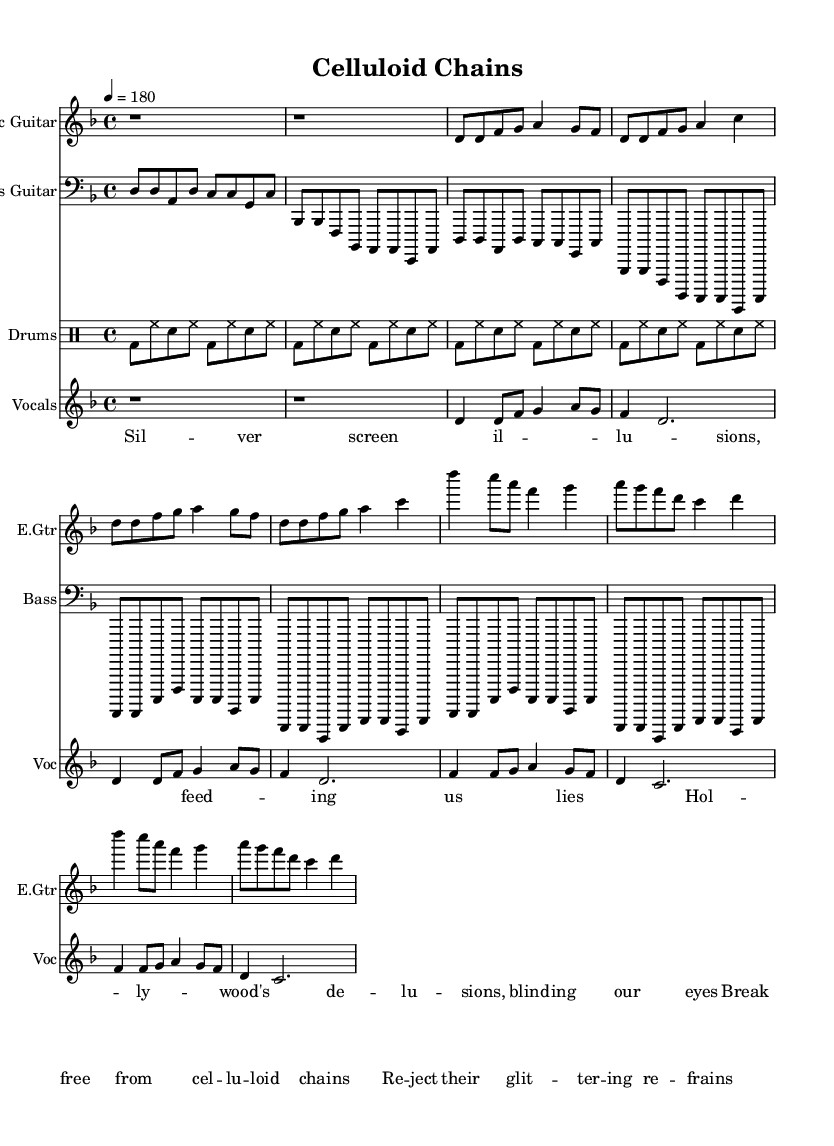What is the time signature of this music? The time signature is indicated at the beginning of the score as 4/4, meaning there are four beats per measure and the quarter note gets one beat.
Answer: 4/4 What is the tempo of this piece? The tempo is indicated by the marking tempo 4 = 180, which means the quarter note is played at a speed of 180 beats per minute.
Answer: 180 What key is this piece composed in? The key signature is specified as D minor, which includes one flat (B flat) and is established at the beginning of the score.
Answer: D minor How many measures are there in the verse section? By analyzing the structure of the score, the verse consists of two repetitions of a four-measure phrase, totaling eight measures in that section.
Answer: 8 What instrument plays the main melody in this piece? Reviewing the score, the vocals part is the one that delivers the main melodic line, as indicated by its placement and notation.
Answer: Vocals What themes are addressed in the lyrics? The lyrics explicitly criticize Hollywood's influence through metaphors, such as "celluloid chains," and express a desire to break free from deception.
Answer: Criticism of Hollywood How is the punk style reflected in the structure of the music? The music features fast tempos, driving rhythms, and strong dynamics characteristic of punk; the rhythmic patterns and lyrical delivery enhance this rebellious style.
Answer: Fast tempos, driving rhythms 